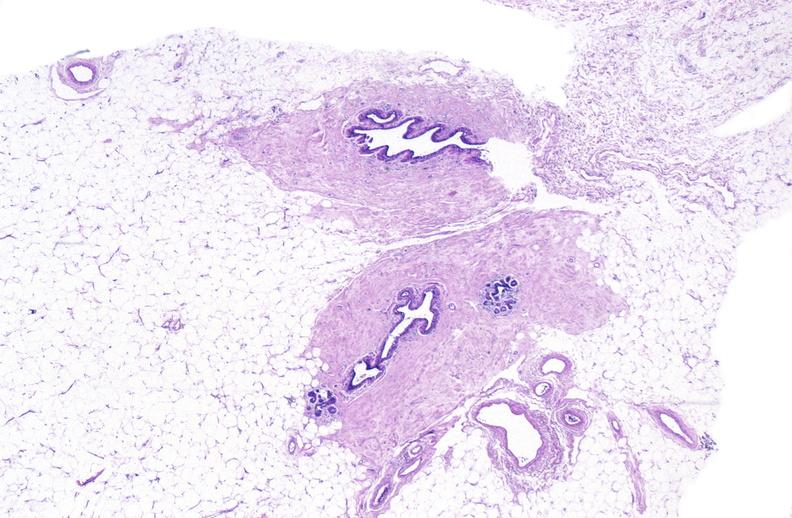does breast show normal breast?
Answer the question using a single word or phrase. No 